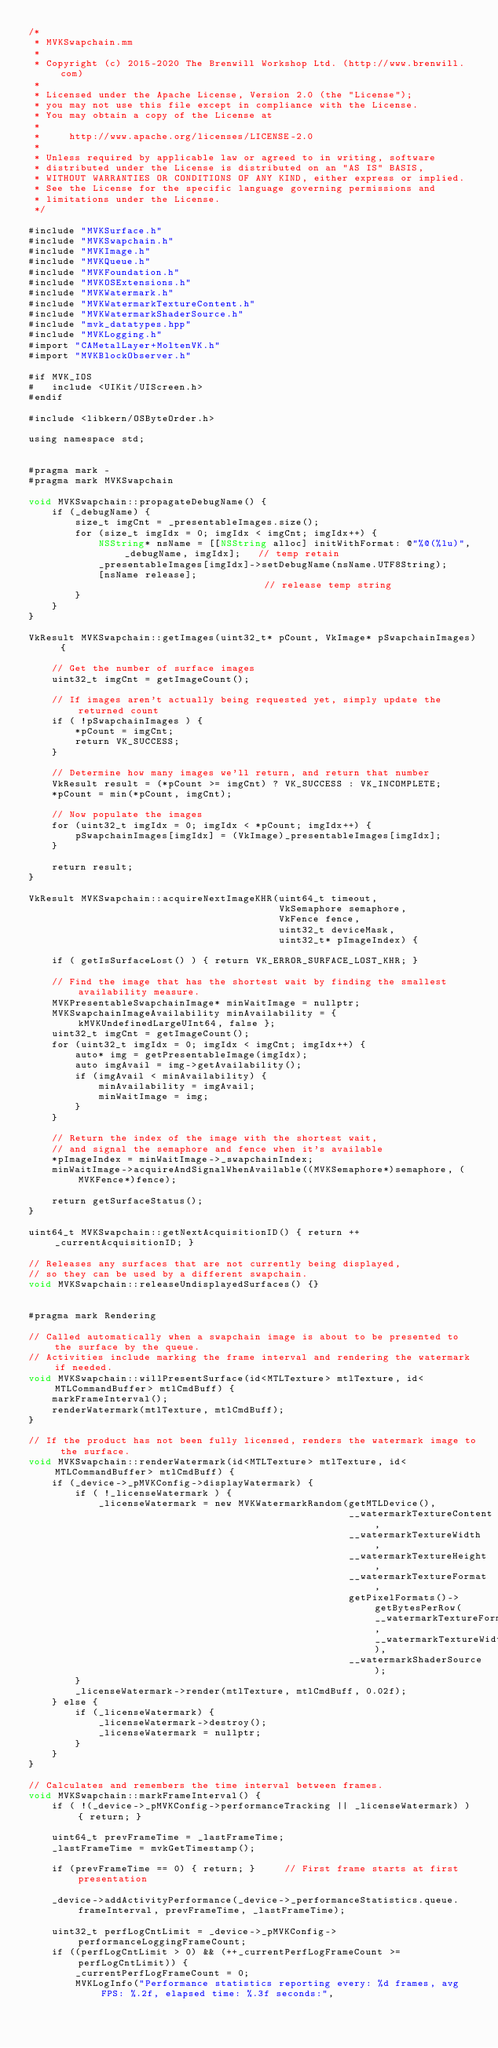<code> <loc_0><loc_0><loc_500><loc_500><_ObjectiveC_>/*
 * MVKSwapchain.mm
 *
 * Copyright (c) 2015-2020 The Brenwill Workshop Ltd. (http://www.brenwill.com)
 *
 * Licensed under the Apache License, Version 2.0 (the "License");
 * you may not use this file except in compliance with the License.
 * You may obtain a copy of the License at
 * 
 *     http://www.apache.org/licenses/LICENSE-2.0
 * 
 * Unless required by applicable law or agreed to in writing, software
 * distributed under the License is distributed on an "AS IS" BASIS,
 * WITHOUT WARRANTIES OR CONDITIONS OF ANY KIND, either express or implied.
 * See the License for the specific language governing permissions and
 * limitations under the License.
 */

#include "MVKSurface.h"
#include "MVKSwapchain.h"
#include "MVKImage.h"
#include "MVKQueue.h"
#include "MVKFoundation.h"
#include "MVKOSExtensions.h"
#include "MVKWatermark.h"
#include "MVKWatermarkTextureContent.h"
#include "MVKWatermarkShaderSource.h"
#include "mvk_datatypes.hpp"
#include "MVKLogging.h"
#import "CAMetalLayer+MoltenVK.h"
#import "MVKBlockObserver.h"

#if MVK_IOS
#	include <UIKit/UIScreen.h>
#endif

#include <libkern/OSByteOrder.h>

using namespace std;


#pragma mark -
#pragma mark MVKSwapchain

void MVKSwapchain::propagateDebugName() {
	if (_debugName) {
		size_t imgCnt = _presentableImages.size();
		for (size_t imgIdx = 0; imgIdx < imgCnt; imgIdx++) {
			NSString* nsName = [[NSString alloc] initWithFormat: @"%@(%lu)", _debugName, imgIdx];	// temp retain
			_presentableImages[imgIdx]->setDebugName(nsName.UTF8String);
			[nsName release];																		// release temp string
		}
	}
}

VkResult MVKSwapchain::getImages(uint32_t* pCount, VkImage* pSwapchainImages) {

	// Get the number of surface images
	uint32_t imgCnt = getImageCount();

	// If images aren't actually being requested yet, simply update the returned count
	if ( !pSwapchainImages ) {
		*pCount = imgCnt;
		return VK_SUCCESS;
	}

	// Determine how many images we'll return, and return that number
	VkResult result = (*pCount >= imgCnt) ? VK_SUCCESS : VK_INCOMPLETE;
	*pCount = min(*pCount, imgCnt);

	// Now populate the images
	for (uint32_t imgIdx = 0; imgIdx < *pCount; imgIdx++) {
		pSwapchainImages[imgIdx] = (VkImage)_presentableImages[imgIdx];
	}

	return result;
}

VkResult MVKSwapchain::acquireNextImageKHR(uint64_t timeout,
										   VkSemaphore semaphore,
										   VkFence fence,
										   uint32_t deviceMask,
										   uint32_t* pImageIndex) {

	if ( getIsSurfaceLost() ) { return VK_ERROR_SURFACE_LOST_KHR; }

	// Find the image that has the shortest wait by finding the smallest availability measure.
	MVKPresentableSwapchainImage* minWaitImage = nullptr;
	MVKSwapchainImageAvailability minAvailability = { kMVKUndefinedLargeUInt64, false };
	uint32_t imgCnt = getImageCount();
	for (uint32_t imgIdx = 0; imgIdx < imgCnt; imgIdx++) {
		auto* img = getPresentableImage(imgIdx);
		auto imgAvail = img->getAvailability();
		if (imgAvail < minAvailability) {
			minAvailability = imgAvail;
			minWaitImage = img;
		}
	}

	// Return the index of the image with the shortest wait,
	// and signal the semaphore and fence when it's available
	*pImageIndex = minWaitImage->_swapchainIndex;
	minWaitImage->acquireAndSignalWhenAvailable((MVKSemaphore*)semaphore, (MVKFence*)fence);

	return getSurfaceStatus();
}

uint64_t MVKSwapchain::getNextAcquisitionID() { return ++_currentAcquisitionID; }

// Releases any surfaces that are not currently being displayed,
// so they can be used by a different swapchain.
void MVKSwapchain::releaseUndisplayedSurfaces() {}


#pragma mark Rendering

// Called automatically when a swapchain image is about to be presented to the surface by the queue.
// Activities include marking the frame interval and rendering the watermark if needed.
void MVKSwapchain::willPresentSurface(id<MTLTexture> mtlTexture, id<MTLCommandBuffer> mtlCmdBuff) {
    markFrameInterval();
    renderWatermark(mtlTexture, mtlCmdBuff);
}

// If the product has not been fully licensed, renders the watermark image to the surface.
void MVKSwapchain::renderWatermark(id<MTLTexture> mtlTexture, id<MTLCommandBuffer> mtlCmdBuff) {
    if (_device->_pMVKConfig->displayWatermark) {
        if ( !_licenseWatermark ) {
            _licenseWatermark = new MVKWatermarkRandom(getMTLDevice(),
                                                       __watermarkTextureContent,
                                                       __watermarkTextureWidth,
                                                       __watermarkTextureHeight,
                                                       __watermarkTextureFormat,
                                                       getPixelFormats()->getBytesPerRow(__watermarkTextureFormat, __watermarkTextureWidth),
                                                       __watermarkShaderSource);
        }
		_licenseWatermark->render(mtlTexture, mtlCmdBuff, 0.02f);
    } else {
        if (_licenseWatermark) {
            _licenseWatermark->destroy();
            _licenseWatermark = nullptr;
        }
    }
}

// Calculates and remembers the time interval between frames.
void MVKSwapchain::markFrameInterval() {
	if ( !(_device->_pMVKConfig->performanceTracking || _licenseWatermark) ) { return; }

	uint64_t prevFrameTime = _lastFrameTime;
	_lastFrameTime = mvkGetTimestamp();

	if (prevFrameTime == 0) { return; }		// First frame starts at first presentation

	_device->addActivityPerformance(_device->_performanceStatistics.queue.frameInterval, prevFrameTime, _lastFrameTime);

	uint32_t perfLogCntLimit = _device->_pMVKConfig->performanceLoggingFrameCount;
	if ((perfLogCntLimit > 0) && (++_currentPerfLogFrameCount >= perfLogCntLimit)) {
		_currentPerfLogFrameCount = 0;
		MVKLogInfo("Performance statistics reporting every: %d frames, avg FPS: %.2f, elapsed time: %.3f seconds:",</code> 